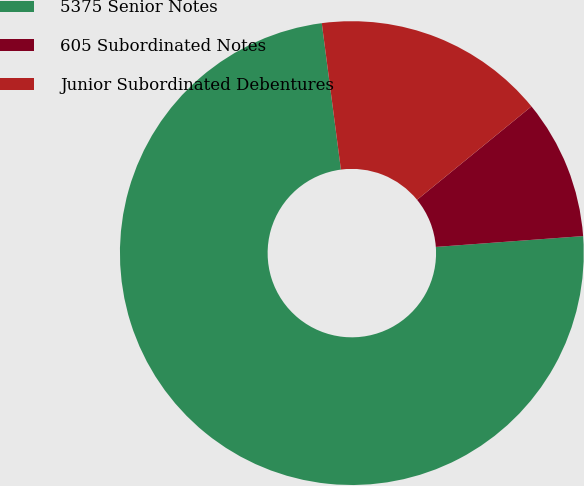Convert chart. <chart><loc_0><loc_0><loc_500><loc_500><pie_chart><fcel>5375 Senior Notes<fcel>605 Subordinated Notes<fcel>Junior Subordinated Debentures<nl><fcel>74.1%<fcel>9.73%<fcel>16.17%<nl></chart> 